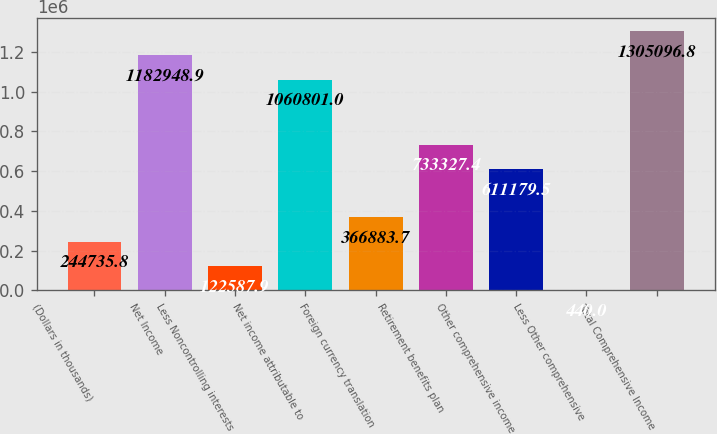<chart> <loc_0><loc_0><loc_500><loc_500><bar_chart><fcel>(Dollars in thousands)<fcel>Net Income<fcel>Less Noncontrolling interests<fcel>Net income attributable to<fcel>Foreign currency translation<fcel>Retirement benefits plan<fcel>Other comprehensive income<fcel>Less Other comprehensive<fcel>Total Comprehensive Income<nl><fcel>244736<fcel>1.18295e+06<fcel>122588<fcel>1.0608e+06<fcel>366884<fcel>733327<fcel>611180<fcel>440<fcel>1.3051e+06<nl></chart> 